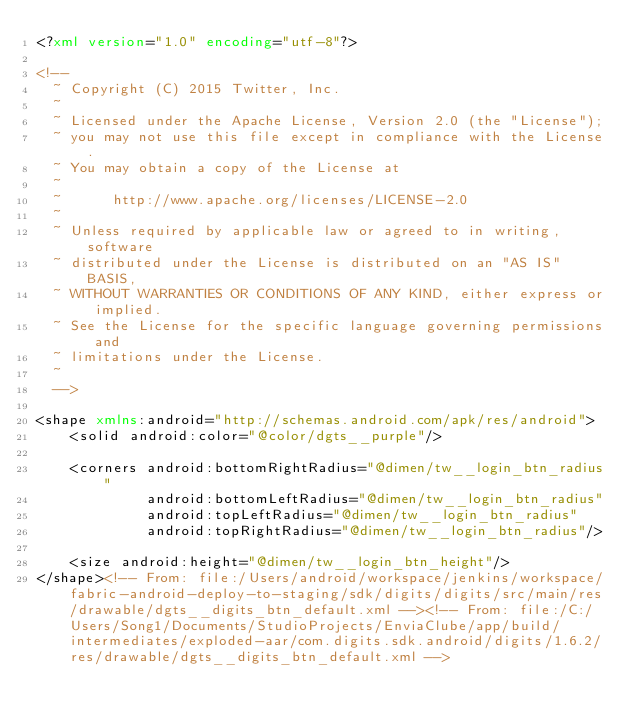Convert code to text. <code><loc_0><loc_0><loc_500><loc_500><_XML_><?xml version="1.0" encoding="utf-8"?>

<!--
  ~ Copyright (C) 2015 Twitter, Inc.
  ~
  ~ Licensed under the Apache License, Version 2.0 (the "License");
  ~ you may not use this file except in compliance with the License.
  ~ You may obtain a copy of the License at
  ~
  ~      http://www.apache.org/licenses/LICENSE-2.0
  ~
  ~ Unless required by applicable law or agreed to in writing, software
  ~ distributed under the License is distributed on an "AS IS" BASIS,
  ~ WITHOUT WARRANTIES OR CONDITIONS OF ANY KIND, either express or implied.
  ~ See the License for the specific language governing permissions and
  ~ limitations under the License.
  ~
  -->

<shape xmlns:android="http://schemas.android.com/apk/res/android">
    <solid android:color="@color/dgts__purple"/>

    <corners android:bottomRightRadius="@dimen/tw__login_btn_radius"
             android:bottomLeftRadius="@dimen/tw__login_btn_radius"
             android:topLeftRadius="@dimen/tw__login_btn_radius"
             android:topRightRadius="@dimen/tw__login_btn_radius"/>

    <size android:height="@dimen/tw__login_btn_height"/>
</shape><!-- From: file:/Users/android/workspace/jenkins/workspace/fabric-android-deploy-to-staging/sdk/digits/digits/src/main/res/drawable/dgts__digits_btn_default.xml --><!-- From: file:/C:/Users/Song1/Documents/StudioProjects/EnviaClube/app/build/intermediates/exploded-aar/com.digits.sdk.android/digits/1.6.2/res/drawable/dgts__digits_btn_default.xml --></code> 